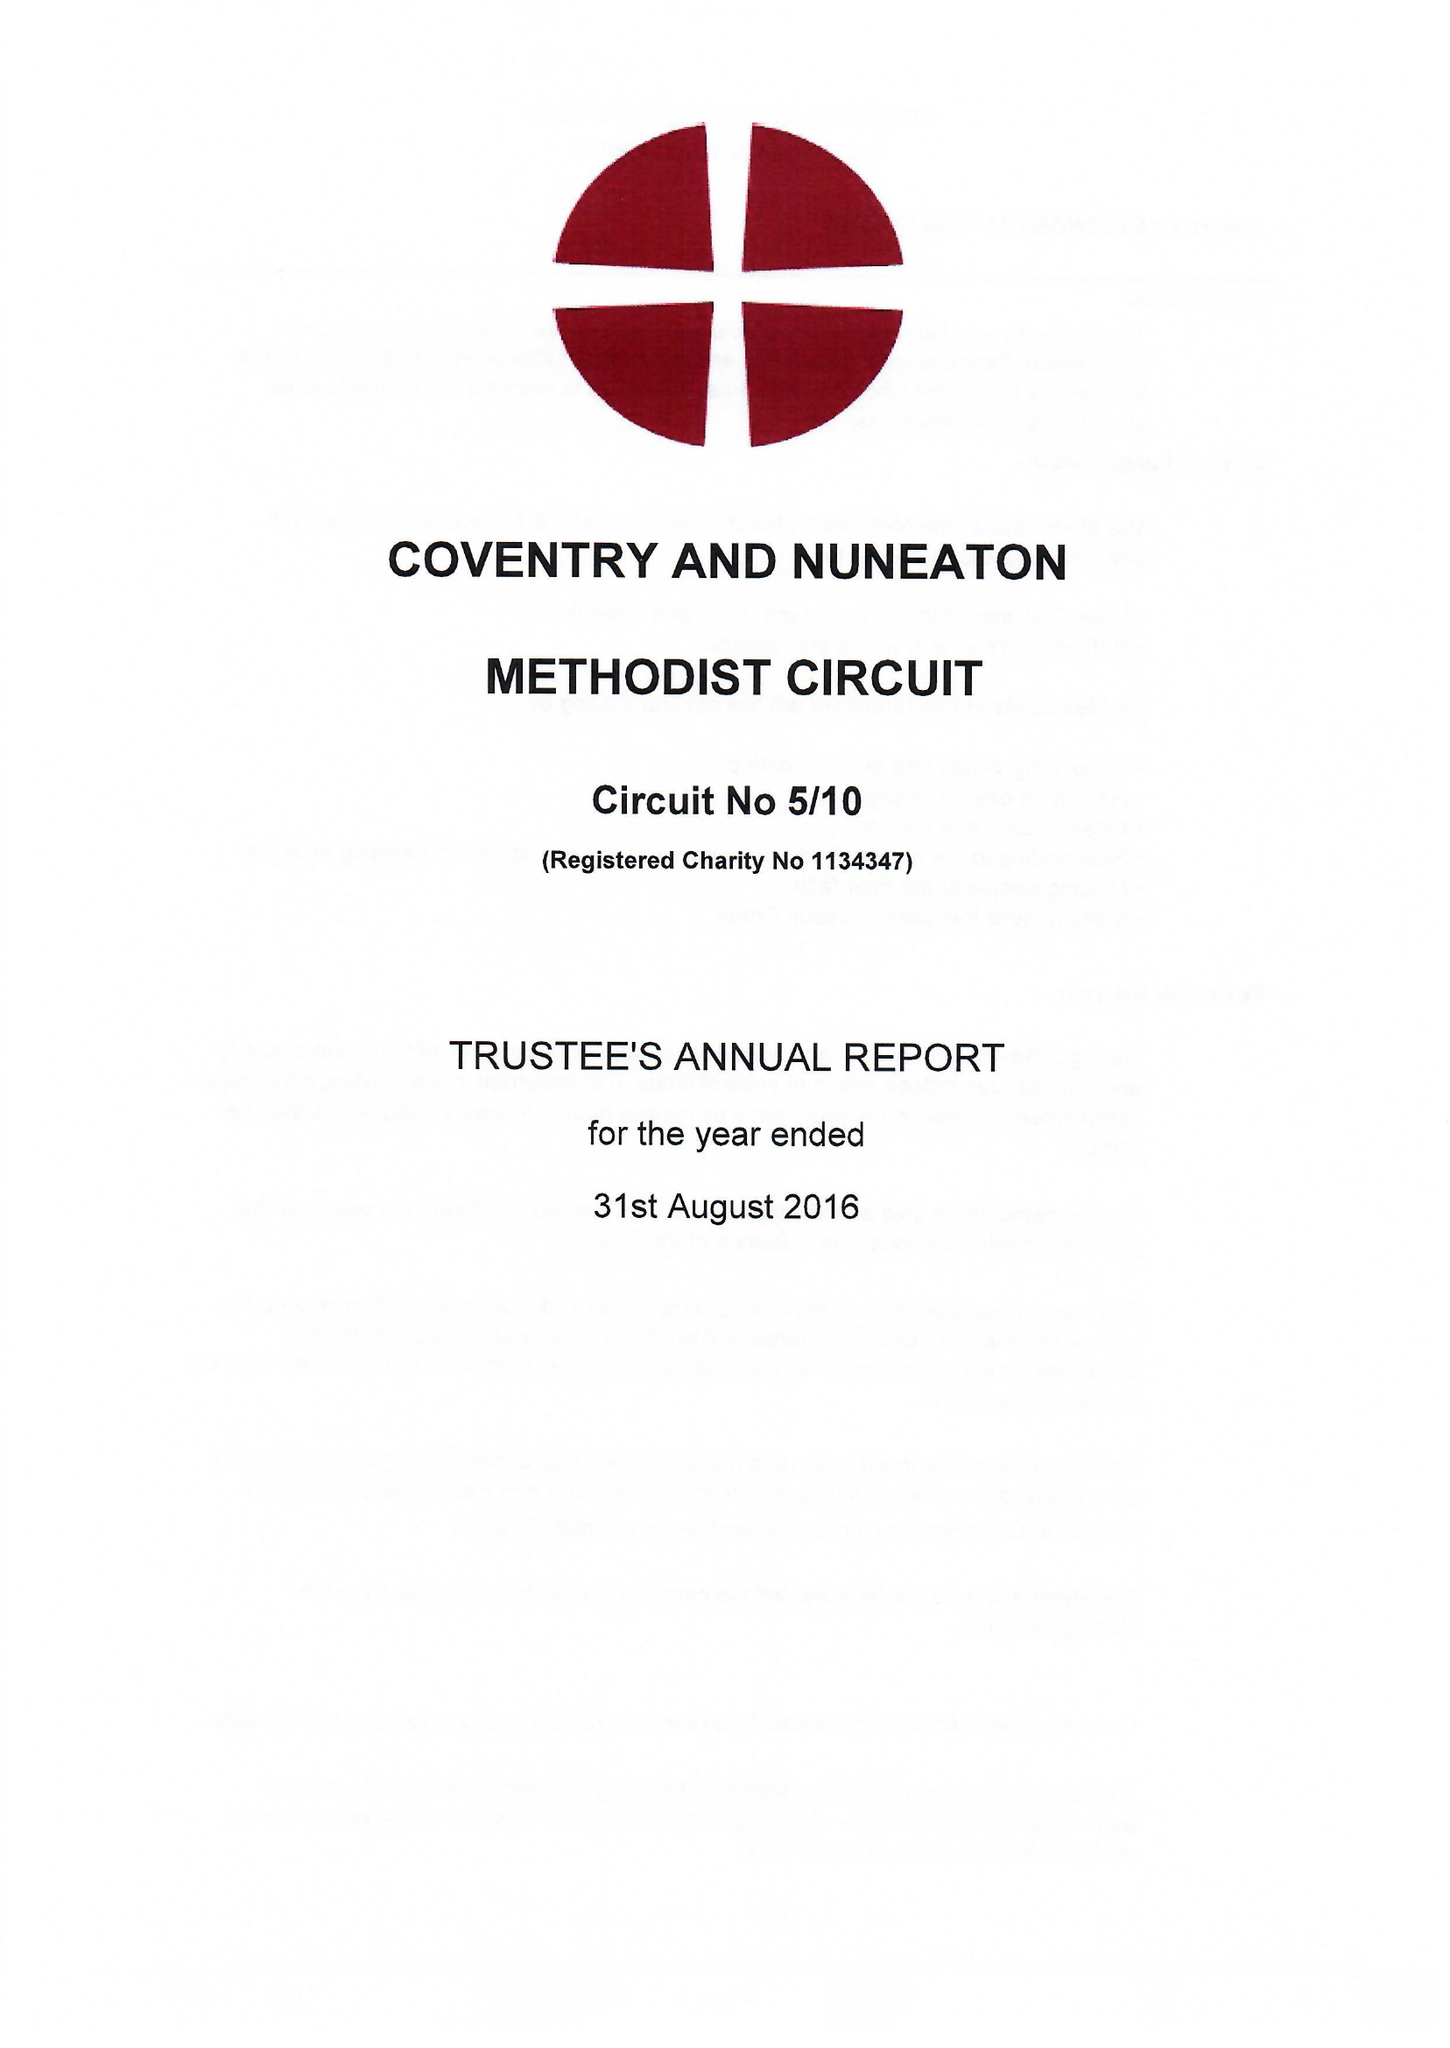What is the value for the report_date?
Answer the question using a single word or phrase. 2016-08-31 